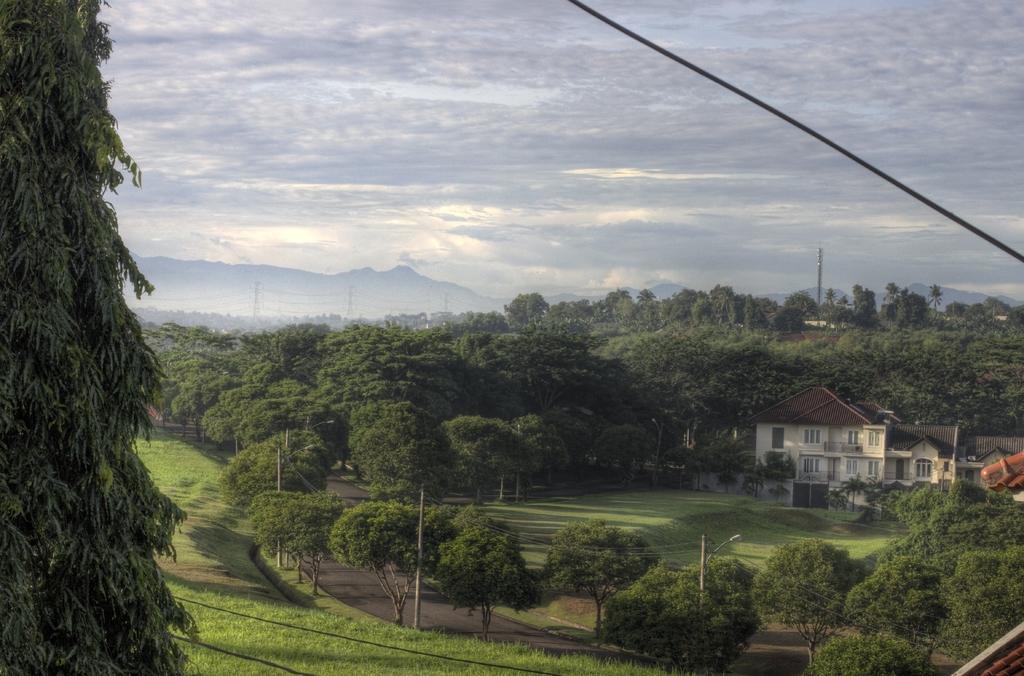Could you give a brief overview of what you see in this image? In this image there are trees and a house, in the background there is a mountain and the sky. 